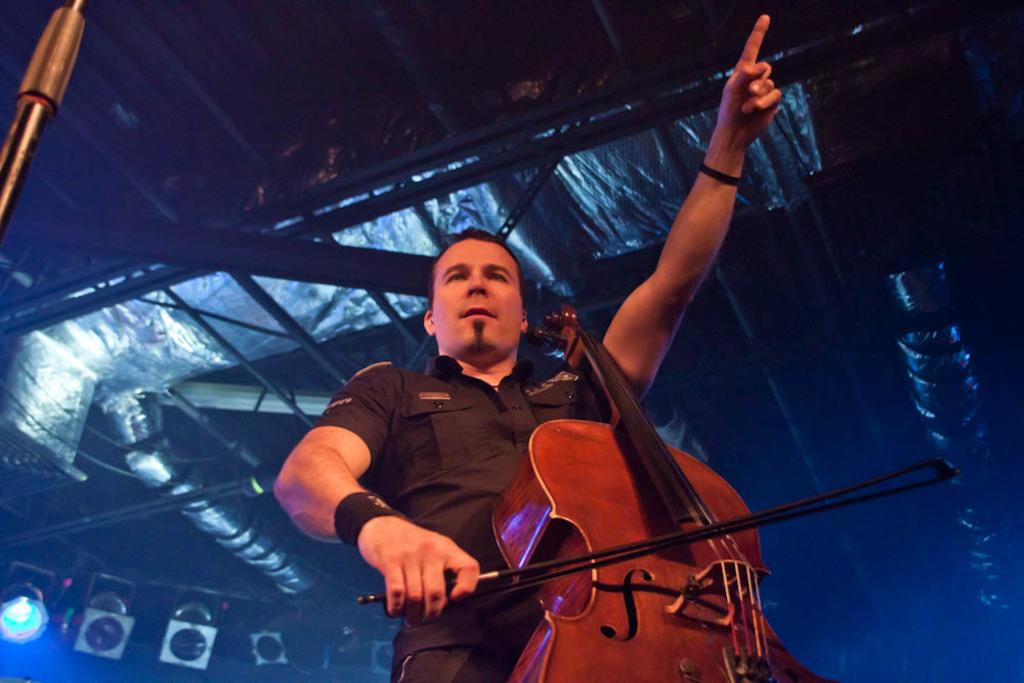What is the main subject of the image? There is a man in the image. What is the man doing in the image? The man is standing and playing the guitar. What else can be seen in the image besides the man? There are lights visible in the image. Where is the playground located in the image? There is no playground present in the image. How many thumbs does the man have on his left hand in the image? The image does not show the man's thumbs, so it cannot be determined how many he has on his left hand. 